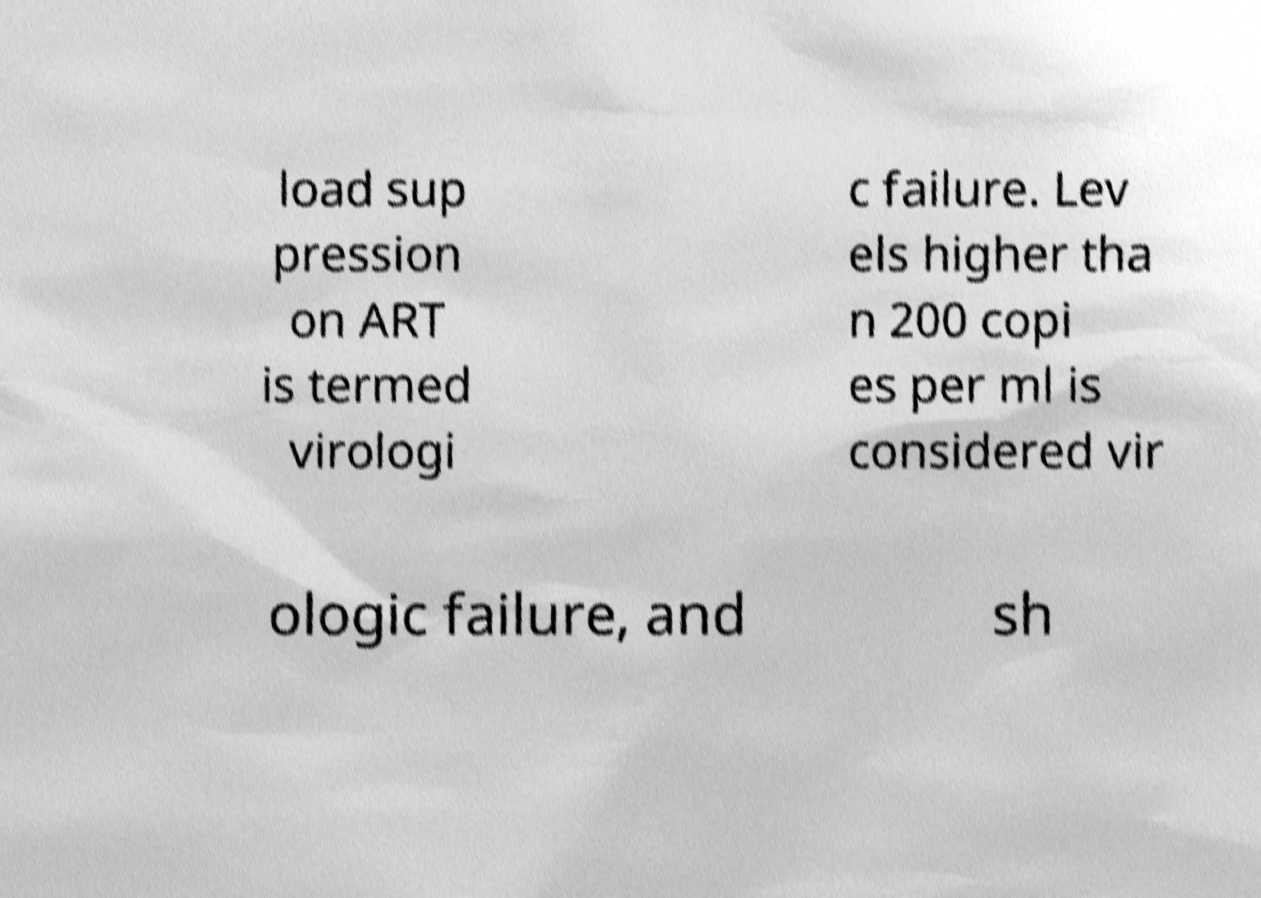I need the written content from this picture converted into text. Can you do that? load sup pression on ART is termed virologi c failure. Lev els higher tha n 200 copi es per ml is considered vir ologic failure, and sh 